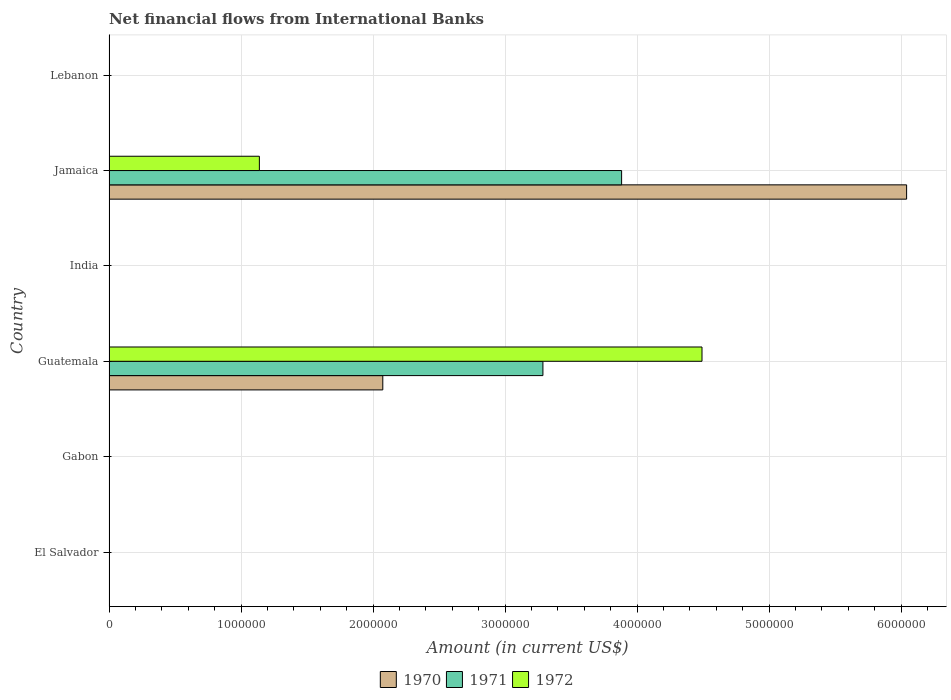How many different coloured bars are there?
Keep it short and to the point. 3. Are the number of bars per tick equal to the number of legend labels?
Provide a short and direct response. No. How many bars are there on the 5th tick from the top?
Ensure brevity in your answer.  0. What is the label of the 6th group of bars from the top?
Provide a short and direct response. El Salvador. What is the net financial aid flows in 1970 in Lebanon?
Your answer should be very brief. 0. Across all countries, what is the maximum net financial aid flows in 1972?
Offer a very short reply. 4.49e+06. In which country was the net financial aid flows in 1972 maximum?
Ensure brevity in your answer.  Guatemala. What is the total net financial aid flows in 1972 in the graph?
Offer a terse response. 5.63e+06. What is the average net financial aid flows in 1970 per country?
Give a very brief answer. 1.35e+06. What is the difference between the net financial aid flows in 1972 and net financial aid flows in 1971 in Guatemala?
Ensure brevity in your answer.  1.20e+06. What is the difference between the highest and the lowest net financial aid flows in 1972?
Provide a succinct answer. 4.49e+06. In how many countries, is the net financial aid flows in 1971 greater than the average net financial aid flows in 1971 taken over all countries?
Provide a short and direct response. 2. How many bars are there?
Make the answer very short. 6. Are all the bars in the graph horizontal?
Your answer should be compact. Yes. Where does the legend appear in the graph?
Keep it short and to the point. Bottom center. How many legend labels are there?
Ensure brevity in your answer.  3. How are the legend labels stacked?
Make the answer very short. Horizontal. What is the title of the graph?
Keep it short and to the point. Net financial flows from International Banks. Does "2010" appear as one of the legend labels in the graph?
Your answer should be very brief. No. What is the label or title of the X-axis?
Keep it short and to the point. Amount (in current US$). What is the label or title of the Y-axis?
Your answer should be very brief. Country. What is the Amount (in current US$) in 1971 in El Salvador?
Provide a succinct answer. 0. What is the Amount (in current US$) in 1972 in Gabon?
Make the answer very short. 0. What is the Amount (in current US$) of 1970 in Guatemala?
Offer a terse response. 2.07e+06. What is the Amount (in current US$) in 1971 in Guatemala?
Make the answer very short. 3.29e+06. What is the Amount (in current US$) in 1972 in Guatemala?
Offer a terse response. 4.49e+06. What is the Amount (in current US$) of 1971 in India?
Keep it short and to the point. 0. What is the Amount (in current US$) in 1972 in India?
Your response must be concise. 0. What is the Amount (in current US$) of 1970 in Jamaica?
Your answer should be compact. 6.04e+06. What is the Amount (in current US$) in 1971 in Jamaica?
Your answer should be compact. 3.88e+06. What is the Amount (in current US$) in 1972 in Jamaica?
Provide a succinct answer. 1.14e+06. What is the Amount (in current US$) of 1972 in Lebanon?
Offer a very short reply. 0. Across all countries, what is the maximum Amount (in current US$) in 1970?
Give a very brief answer. 6.04e+06. Across all countries, what is the maximum Amount (in current US$) in 1971?
Your answer should be very brief. 3.88e+06. Across all countries, what is the maximum Amount (in current US$) of 1972?
Your answer should be compact. 4.49e+06. What is the total Amount (in current US$) of 1970 in the graph?
Offer a terse response. 8.12e+06. What is the total Amount (in current US$) in 1971 in the graph?
Give a very brief answer. 7.17e+06. What is the total Amount (in current US$) in 1972 in the graph?
Your response must be concise. 5.63e+06. What is the difference between the Amount (in current US$) of 1970 in Guatemala and that in Jamaica?
Ensure brevity in your answer.  -3.97e+06. What is the difference between the Amount (in current US$) in 1971 in Guatemala and that in Jamaica?
Make the answer very short. -5.96e+05. What is the difference between the Amount (in current US$) in 1972 in Guatemala and that in Jamaica?
Offer a very short reply. 3.35e+06. What is the difference between the Amount (in current US$) of 1970 in Guatemala and the Amount (in current US$) of 1971 in Jamaica?
Give a very brief answer. -1.81e+06. What is the difference between the Amount (in current US$) of 1970 in Guatemala and the Amount (in current US$) of 1972 in Jamaica?
Your answer should be very brief. 9.35e+05. What is the difference between the Amount (in current US$) of 1971 in Guatemala and the Amount (in current US$) of 1972 in Jamaica?
Ensure brevity in your answer.  2.15e+06. What is the average Amount (in current US$) of 1970 per country?
Provide a succinct answer. 1.35e+06. What is the average Amount (in current US$) of 1971 per country?
Your response must be concise. 1.20e+06. What is the average Amount (in current US$) in 1972 per country?
Ensure brevity in your answer.  9.38e+05. What is the difference between the Amount (in current US$) in 1970 and Amount (in current US$) in 1971 in Guatemala?
Offer a terse response. -1.21e+06. What is the difference between the Amount (in current US$) of 1970 and Amount (in current US$) of 1972 in Guatemala?
Give a very brief answer. -2.42e+06. What is the difference between the Amount (in current US$) in 1971 and Amount (in current US$) in 1972 in Guatemala?
Offer a very short reply. -1.20e+06. What is the difference between the Amount (in current US$) in 1970 and Amount (in current US$) in 1971 in Jamaica?
Your response must be concise. 2.16e+06. What is the difference between the Amount (in current US$) of 1970 and Amount (in current US$) of 1972 in Jamaica?
Offer a terse response. 4.90e+06. What is the difference between the Amount (in current US$) in 1971 and Amount (in current US$) in 1972 in Jamaica?
Keep it short and to the point. 2.74e+06. What is the ratio of the Amount (in current US$) of 1970 in Guatemala to that in Jamaica?
Your answer should be very brief. 0.34. What is the ratio of the Amount (in current US$) of 1971 in Guatemala to that in Jamaica?
Your answer should be compact. 0.85. What is the ratio of the Amount (in current US$) in 1972 in Guatemala to that in Jamaica?
Your answer should be very brief. 3.94. What is the difference between the highest and the lowest Amount (in current US$) of 1970?
Give a very brief answer. 6.04e+06. What is the difference between the highest and the lowest Amount (in current US$) in 1971?
Keep it short and to the point. 3.88e+06. What is the difference between the highest and the lowest Amount (in current US$) of 1972?
Your answer should be compact. 4.49e+06. 